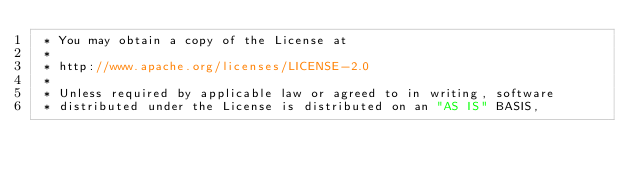<code> <loc_0><loc_0><loc_500><loc_500><_Java_> * You may obtain a copy of the License at
 *
 * http://www.apache.org/licenses/LICENSE-2.0
 *
 * Unless required by applicable law or agreed to in writing, software
 * distributed under the License is distributed on an "AS IS" BASIS,</code> 